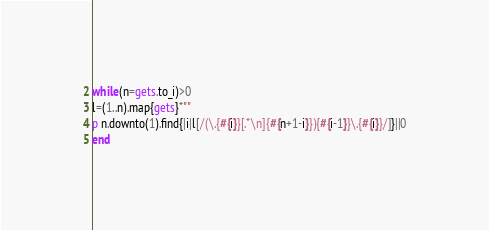<code> <loc_0><loc_0><loc_500><loc_500><_Ruby_>while(n=gets.to_i)>0
l=(1..n).map{gets}*""
p n.downto(1).find{|i|l[/(\.{#{i}}[.*\n]{#{n+1-i}}){#{i-1}}\.{#{i}}/]}||0
end</code> 